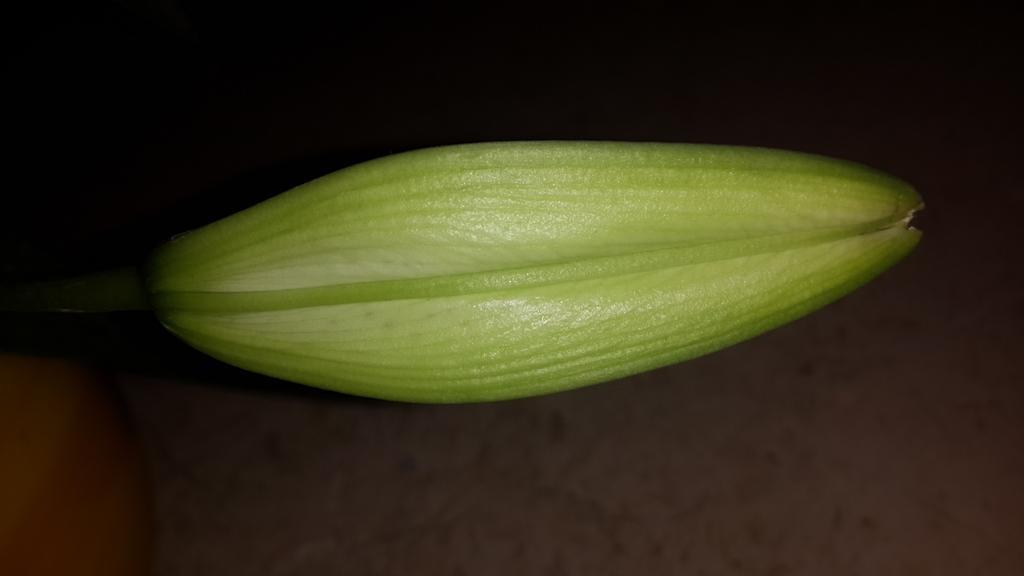Describe this image in one or two sentences. In this image there is a bud of a flower. 